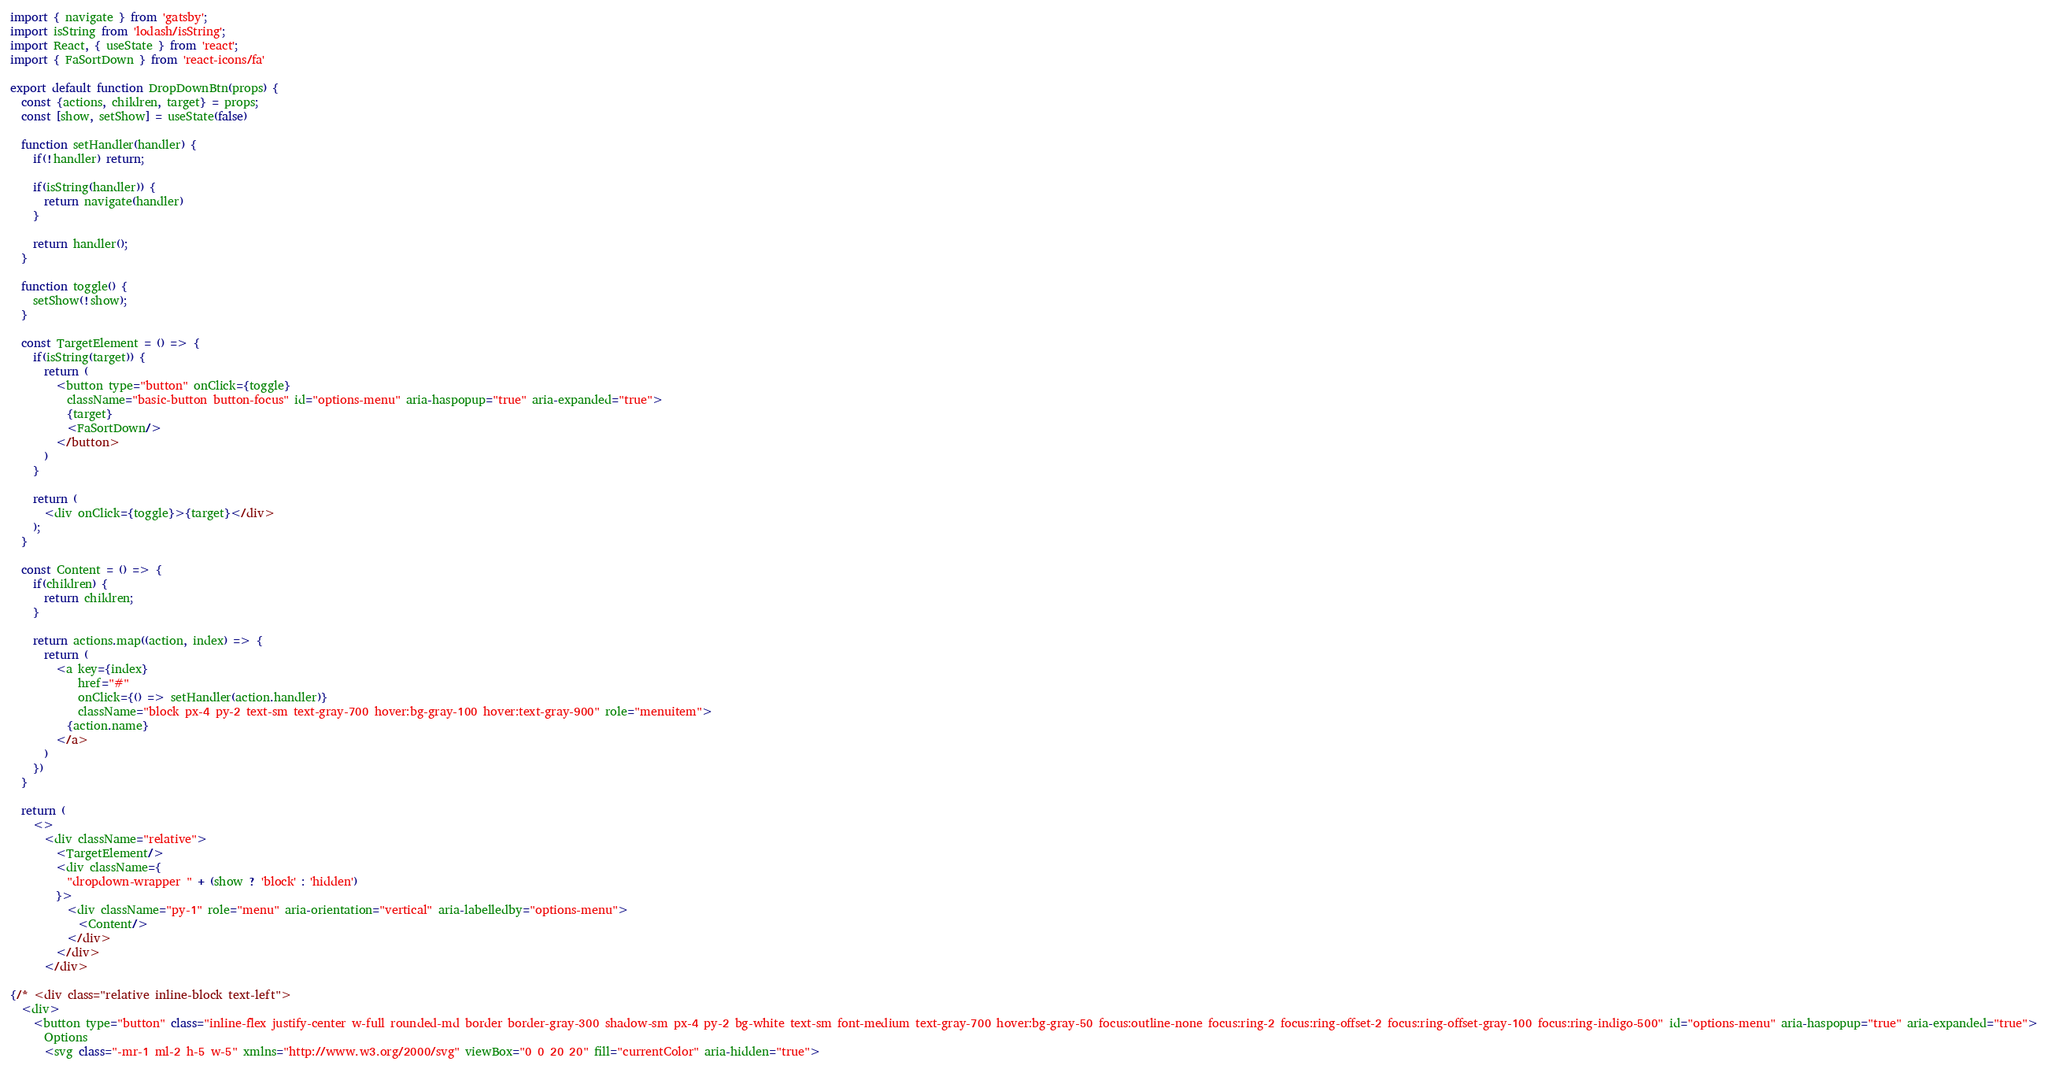Convert code to text. <code><loc_0><loc_0><loc_500><loc_500><_JavaScript_>import { navigate } from 'gatsby';
import isString from 'lodash/isString';
import React, { useState } from 'react';
import { FaSortDown } from 'react-icons/fa'

export default function DropDownBtn(props) {
  const {actions, children, target} = props;
  const [show, setShow] = useState(false)

  function setHandler(handler) {
    if(!handler) return;

    if(isString(handler)) {
      return navigate(handler)
    }

    return handler();
  }

  function toggle() {
    setShow(!show);
  }

  const TargetElement = () => {
    if(isString(target)) {
      return (
        <button type="button" onClick={toggle}
          className="basic-button button-focus" id="options-menu" aria-haspopup="true" aria-expanded="true">
          {target}
          <FaSortDown/>
        </button>
      )
    }

    return (
      <div onClick={toggle}>{target}</div>
    );
  }

  const Content = () => {
    if(children) {
      return children;
    }

    return actions.map((action, index) => {
      return (
        <a key={index}
            href="#"
            onClick={() => setHandler(action.handler)}
            className="block px-4 py-2 text-sm text-gray-700 hover:bg-gray-100 hover:text-gray-900" role="menuitem">
          {action.name}
        </a>
      )
    })
  }

  return (
    <>
      <div className="relative">
        <TargetElement/>
        <div className={
          "dropdown-wrapper " + (show ? 'block' : 'hidden') 
        }>
          <div className="py-1" role="menu" aria-orientation="vertical" aria-labelledby="options-menu">
            <Content/>
          </div>
        </div>
      </div>

{/* <div class="relative inline-block text-left">
  <div>
    <button type="button" class="inline-flex justify-center w-full rounded-md border border-gray-300 shadow-sm px-4 py-2 bg-white text-sm font-medium text-gray-700 hover:bg-gray-50 focus:outline-none focus:ring-2 focus:ring-offset-2 focus:ring-offset-gray-100 focus:ring-indigo-500" id="options-menu" aria-haspopup="true" aria-expanded="true">
      Options
      <svg class="-mr-1 ml-2 h-5 w-5" xmlns="http://www.w3.org/2000/svg" viewBox="0 0 20 20" fill="currentColor" aria-hidden="true"></code> 